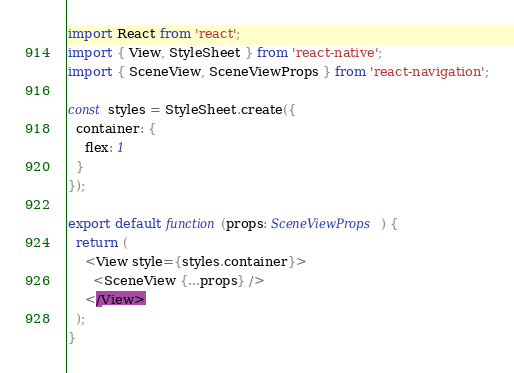Convert code to text. <code><loc_0><loc_0><loc_500><loc_500><_TypeScript_>import React from 'react';
import { View, StyleSheet } from 'react-native';
import { SceneView, SceneViewProps } from 'react-navigation';

const styles = StyleSheet.create({
  container: {
    flex: 1
  }
});

export default function(props: SceneViewProps) {
  return (
    <View style={styles.container}>
      <SceneView {...props} />
    </View>
  );
}
</code> 